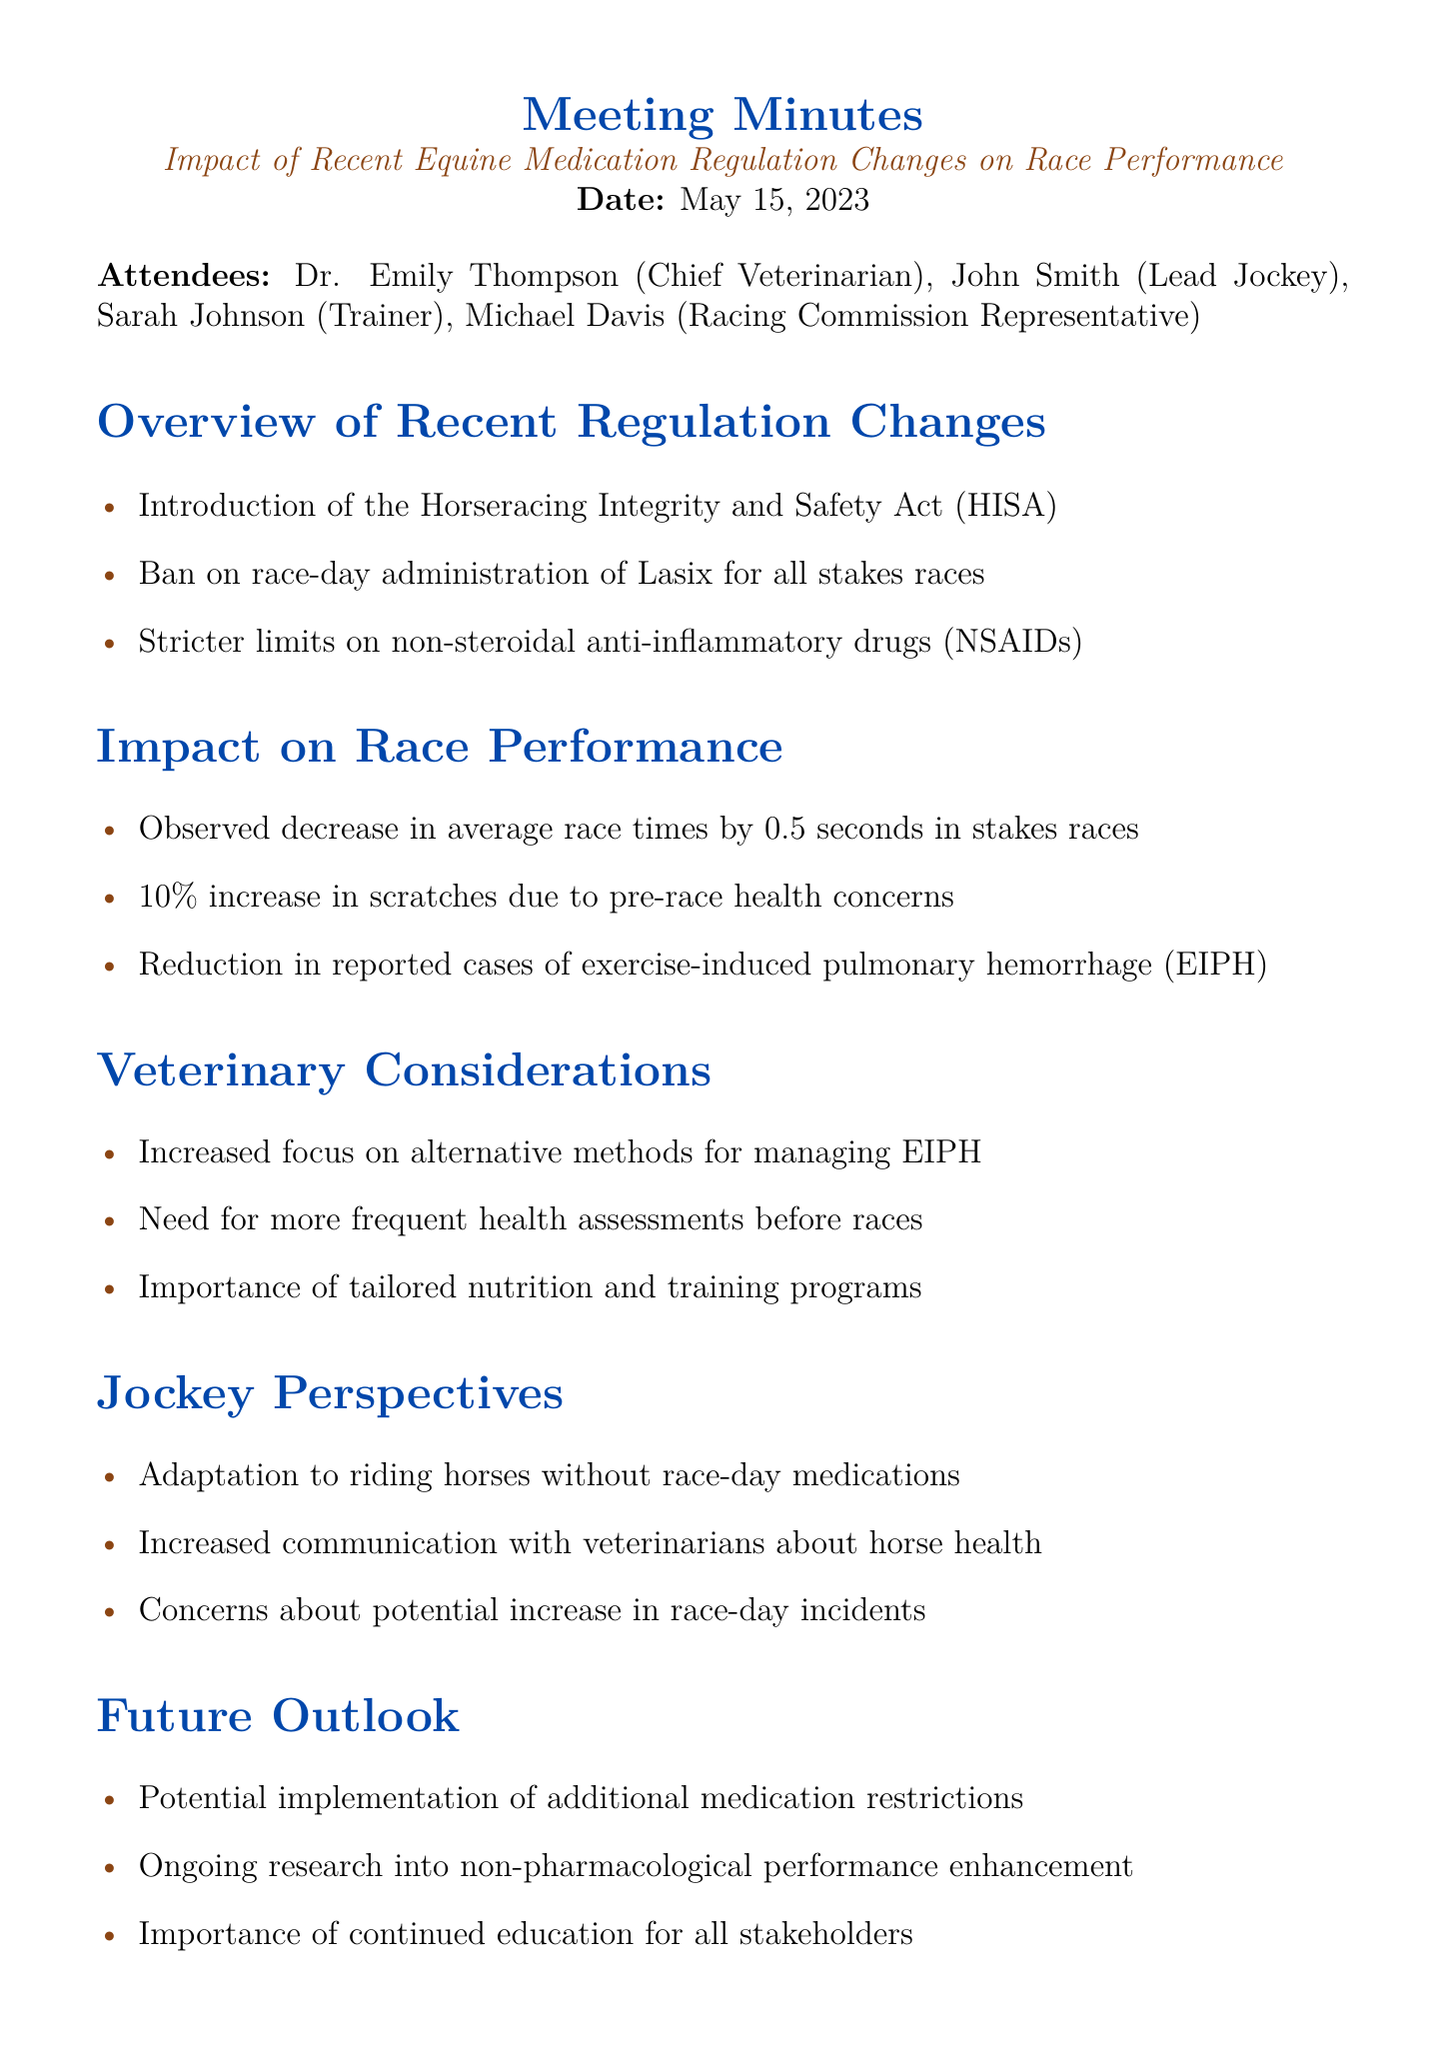What is the meeting title? The meeting title is explicitly mentioned at the top of the document, which is "Impact of Recent Equine Medication Regulation Changes on Race Performance."
Answer: Impact of Recent Equine Medication Regulation Changes on Race Performance Who is the Chief Veterinarian? The document lists Dr. Emily Thompson as the Chief Veterinarian among the attendees.
Answer: Dr. Emily Thompson What date was the meeting held? The date of the meeting is clearly stated in the document.
Answer: May 15, 2023 What is one regulation change mentioned? The document lists multiple regulation changes under the "Overview of Recent Regulation Changes" section. One of them is the "Ban on race-day administration of Lasix for all stakes races."
Answer: Ban on race-day administration of Lasix for all stakes races What is the observed decrease in average race times? The document provides a specific numerical decrease under the "Impact on Race Performance" section.
Answer: 0.5 seconds What percentage increase in scratches was noted? The percentage increase in scratches due to pre-race health concerns is specifically stated in the document.
Answer: 10% What are two veterinary considerations discussed? Looking at the "Veterinary Considerations" section, we can identify more than one focus area. Examples include "Increased focus on alternative methods for managing EIPH" and "Need for more frequent health assessments before races."
Answer: Increased focus on alternative methods for managing EIPH, Need for more frequent health assessments before races What is one concern expressed by jockeys? Under the "Jockey Perspectives" section, one specific concern noted relates to race-day incidents.
Answer: Concerns about potential increase in race-day incidents What is one future outlook mentioned? The document outlines future considerations, one of which is "Potential implementation of additional medication restrictions."
Answer: Potential implementation of additional medication restrictions 